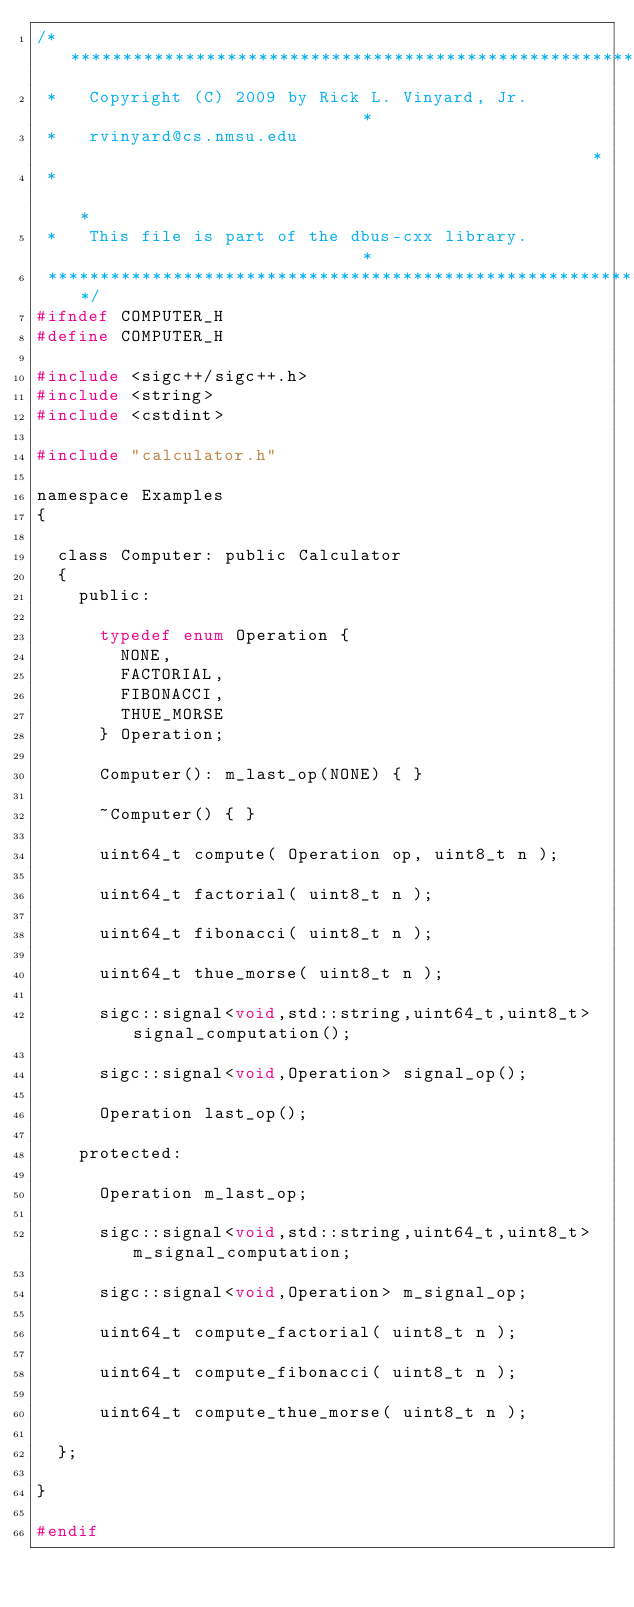Convert code to text. <code><loc_0><loc_0><loc_500><loc_500><_C_>/***************************************************************************
 *   Copyright (C) 2009 by Rick L. Vinyard, Jr.                            *
 *   rvinyard@cs.nmsu.edu                                                  *
 *                                                                         *
 *   This file is part of the dbus-cxx library.                            *
 ***************************************************************************/
#ifndef COMPUTER_H
#define COMPUTER_H

#include <sigc++/sigc++.h>
#include <string>
#include <cstdint>

#include "calculator.h"

namespace Examples
{

  class Computer: public Calculator
  {
    public:

      typedef enum Operation {
        NONE,
        FACTORIAL,
        FIBONACCI,
        THUE_MORSE
      } Operation;

      Computer(): m_last_op(NONE) { }

      ~Computer() { }

      uint64_t compute( Operation op, uint8_t n );

      uint64_t factorial( uint8_t n );

      uint64_t fibonacci( uint8_t n );

      uint64_t thue_morse( uint8_t n );

      sigc::signal<void,std::string,uint64_t,uint8_t> signal_computation();

      sigc::signal<void,Operation> signal_op();

      Operation last_op();

    protected:

      Operation m_last_op;

      sigc::signal<void,std::string,uint64_t,uint8_t> m_signal_computation;

      sigc::signal<void,Operation> m_signal_op;

      uint64_t compute_factorial( uint8_t n );

      uint64_t compute_fibonacci( uint8_t n );

      uint64_t compute_thue_morse( uint8_t n );

  };

}

#endif
</code> 